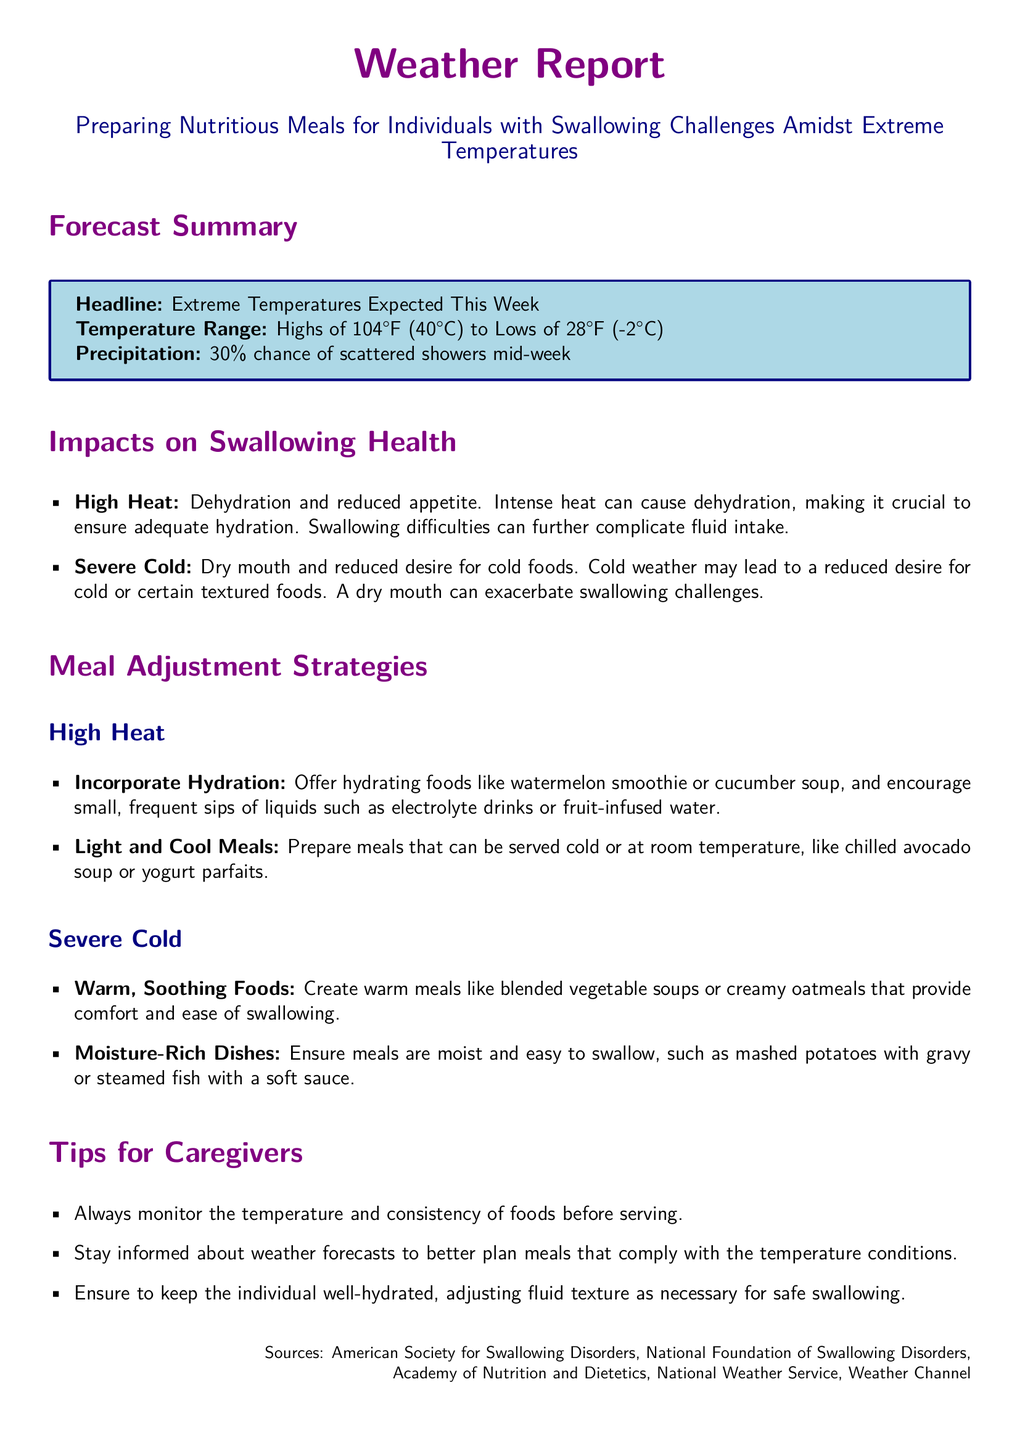What is the expected high temperature this week? The high temperature expected this week is stated in the forecast summary, which lists "Highs of 104°F (40°C)."
Answer: 104°F (40°C) What is the expected low temperature this week? The low temperature expected this week is found in the forecast summary, mentioning "Lows of 28°F (-2°C)."
Answer: 28°F (-2°C) What percentage chance of precipitation is there mid-week? The chance of precipitation is given in the forecast summary section, noting "30% chance of scattered showers mid-week."
Answer: 30% What food type is suggested for hydration during high heat? The meal adjustment strategies for high heat include "hydrating foods like watermelon smoothie."
Answer: watermelon smoothie What type of meal is recommended for severe cold? The document recommends "warm meals like blended vegetable soups" to accommodate swallowing challenges in cold weather.
Answer: warm meals like blended vegetable soups How should caregivers adapt to temperature changes? Caregivers should "stay informed about weather forecasts to better plan meals" as a primary adaptation strategy listed in the tips.
Answer: stay informed about weather forecasts What is suggested to ensure meals are easy to swallow during severe cold? The document mentions ensuring meals are "moist and easy to swallow, such as mashed potatoes with gravy."
Answer: moist and easy to swallow, such as mashed potatoes with gravy What hydration strategy is recommended for high heat? The strategies suggest "encouraging small, frequent sips of liquids such as electrolyte drinks."
Answer: encouraging small, frequent sips of liquids such as electrolyte drinks 